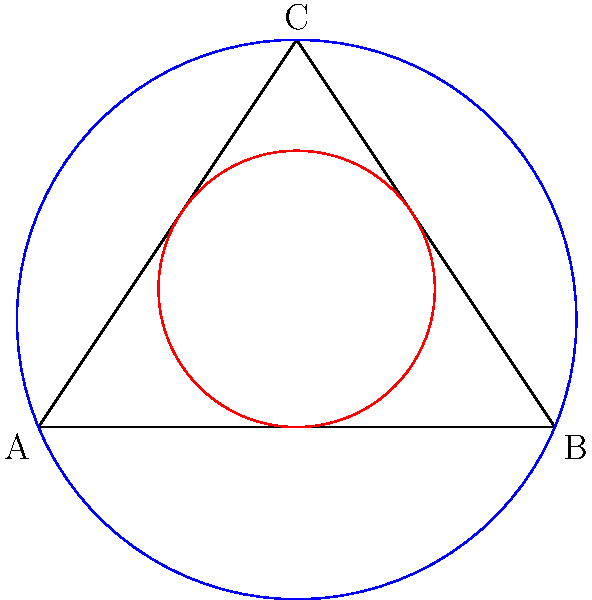In the diagram representing the complex relationships between the main characters of "La Casa de Papel", a triangle ABC symbolizes the core trio. The inscribed circle (red) represents their inner circle of trust, while the circumscribed circle (blue) represents the larger heist plan. If the radius of the inscribed circle is r and the radius of the circumscribed circle is R, what is the ratio of r to R in terms of the semi-perimeter s and the area A of the triangle? Let's approach this step-by-step:

1) For any triangle, the area A can be expressed as:
   $$A = rs$$
   where r is the inradius and s is the semi-perimeter.

2) The area of a triangle can also be expressed using the circumradius R:
   $$A = \frac{abc}{4R}$$
   where a, b, and c are the side lengths of the triangle.

3) The semi-perimeter s is defined as:
   $$s = \frac{a + b + c}{2}$$

4) From steps 1 and 2, we can equate:
   $$rs = \frac{abc}{4R}$$

5) Dividing both sides by $abc$:
   $$\frac{rs}{abc} = \frac{1}{4R}$$

6) Recall that $s = \frac{a + b + c}{2}$, so $2s = a + b + c$

7) Multiplying both sides of the equation from step 5 by $2s$:
   $$\frac{2rs^2}{abc} = \frac{a + b + c}{2abc} \cdot \frac{1}{R} = \frac{1}{R}$$

8) Therefore:
   $$\frac{r}{R} = \frac{A}{s^2}$$

This ratio elegantly captures the relationship between the inner circle of trust (r) and the larger heist plan (R) in terms of the area of influence (A) and the total resources available (represented by s^2).
Answer: $$\frac{r}{R} = \frac{A}{s^2}$$ 